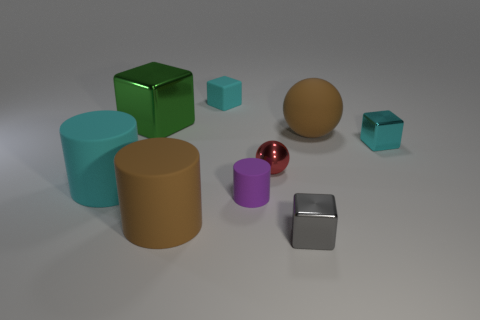Is the number of tiny cyan objects on the right side of the small gray metal block greater than the number of tiny purple matte things?
Your response must be concise. No. There is a small block that is on the right side of the tiny gray thing that is in front of the cyan rubber thing that is in front of the green metallic cube; what is it made of?
Ensure brevity in your answer.  Metal. Is the cyan cylinder made of the same material as the cylinder that is in front of the small purple cylinder?
Your response must be concise. Yes. There is a large brown object that is the same shape as the small purple thing; what is its material?
Provide a succinct answer. Rubber. Are there more tiny metallic balls that are in front of the purple cylinder than big balls in front of the green block?
Make the answer very short. No. What is the shape of the tiny purple thing that is the same material as the large cyan cylinder?
Offer a very short reply. Cylinder. What number of other objects are there of the same shape as the small gray thing?
Your answer should be compact. 3. The tiny rubber object behind the small purple cylinder has what shape?
Provide a short and direct response. Cube. The matte cube has what color?
Make the answer very short. Cyan. What number of other objects are there of the same size as the cyan shiny object?
Your answer should be very brief. 4. 